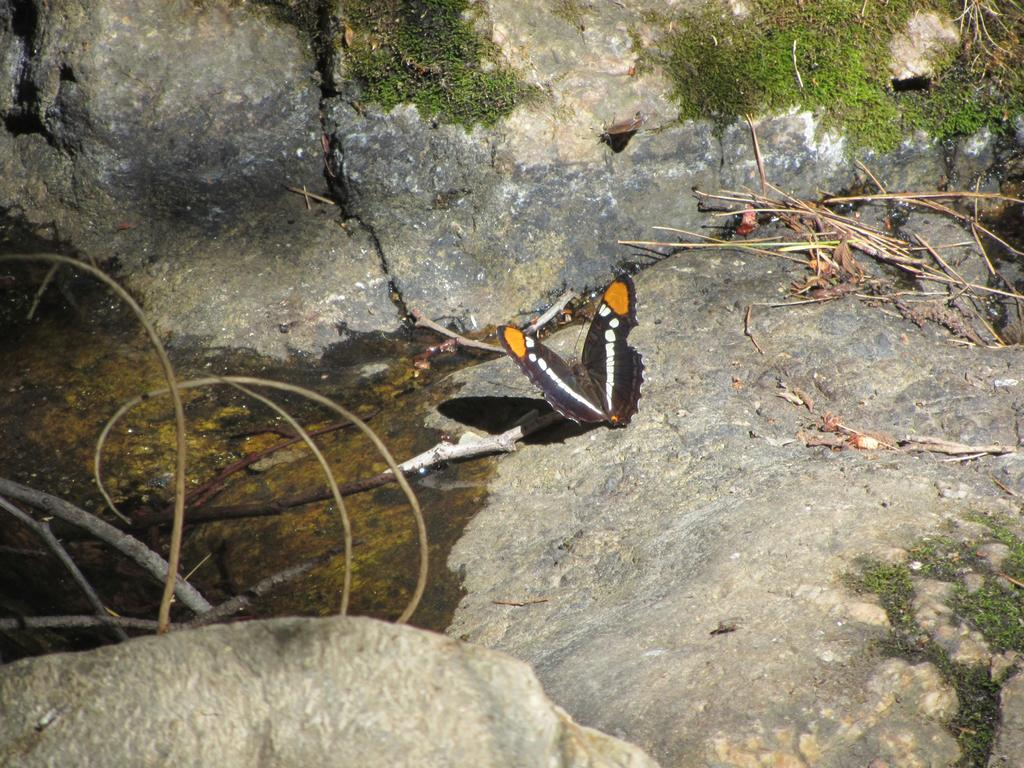What type of animals are present in the image? There are butterflies in the image. Where are the butterflies located? The butterflies are on a rock. What type of club can be seen in the image? There is no club present in the image; it features butterflies on a rock. What type of scale is used by the butterflies in the image? Butterflies do not use scales in the way humans do, and there is no scale present in the image. 